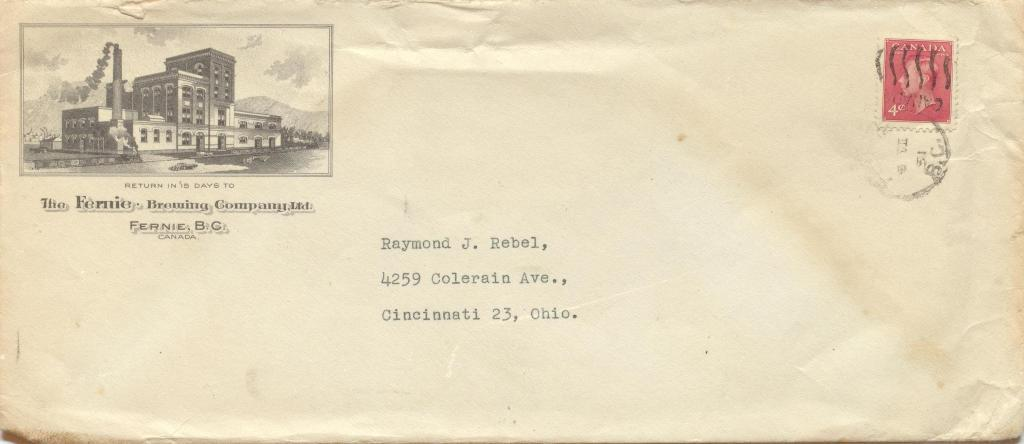Provide a one-sentence caption for the provided image. Envelope address to Raymond J. Rebel with a picture of a building on the corner. 